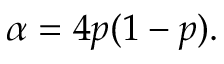Convert formula to latex. <formula><loc_0><loc_0><loc_500><loc_500>\alpha = 4 p ( 1 - p ) .</formula> 